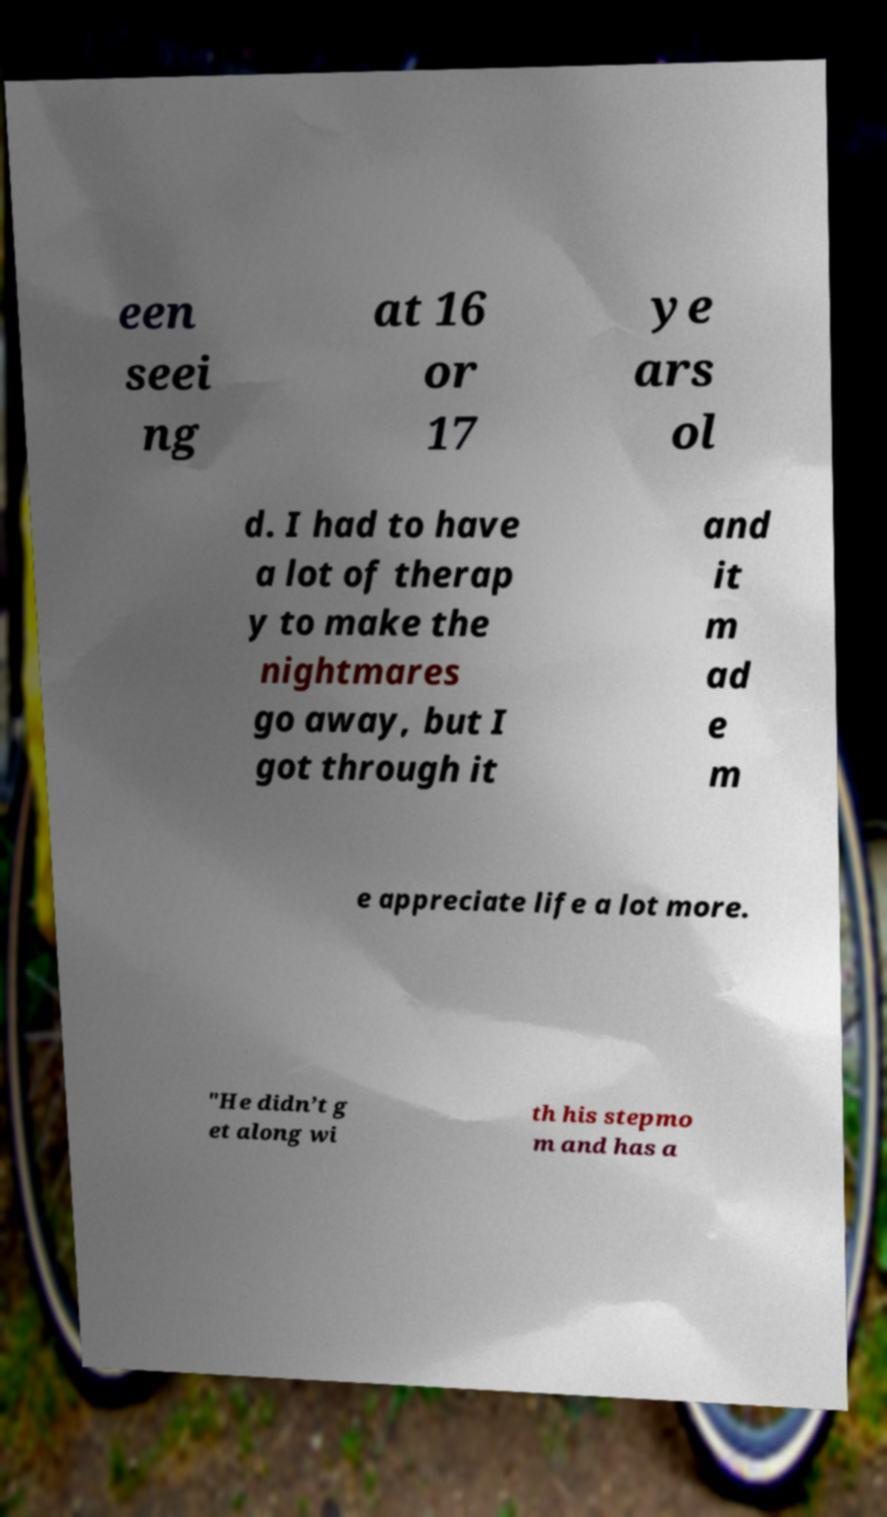What messages or text are displayed in this image? I need them in a readable, typed format. een seei ng at 16 or 17 ye ars ol d. I had to have a lot of therap y to make the nightmares go away, but I got through it and it m ad e m e appreciate life a lot more. "He didn’t g et along wi th his stepmo m and has a 